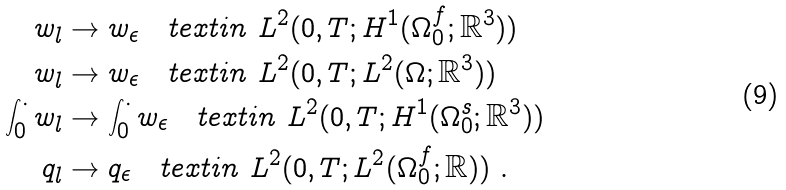<formula> <loc_0><loc_0><loc_500><loc_500>w _ { l } & \rightarrow w _ { \epsilon } \quad t e x t { i n } \ L ^ { 2 } ( 0 , T ; H ^ { 1 } ( \Omega _ { 0 } ^ { f } ; { \mathbb { R } } ^ { 3 } ) ) \\ { w _ { l } } & \rightarrow { w _ { \epsilon } } \quad t e x t { i n } \ L ^ { 2 } ( 0 , T ; L ^ { 2 } ( \Omega ; { \mathbb { R } } ^ { 3 } ) ) \\ \int _ { 0 } ^ { \cdot } { w _ { l } } & \rightarrow \int _ { 0 } ^ { \cdot } { w _ { \epsilon } } \quad t e x t { i n } \ L ^ { 2 } ( 0 , T ; H ^ { 1 } ( \Omega _ { 0 } ^ { s } ; { \mathbb { R } } ^ { 3 } ) ) \\ { q _ { l } } & \rightarrow { q _ { \epsilon } } \quad t e x t { i n } \ L ^ { 2 } ( 0 , T ; L ^ { 2 } ( \Omega _ { 0 } ^ { f } ; { \mathbb { R } } ) ) \ .</formula> 